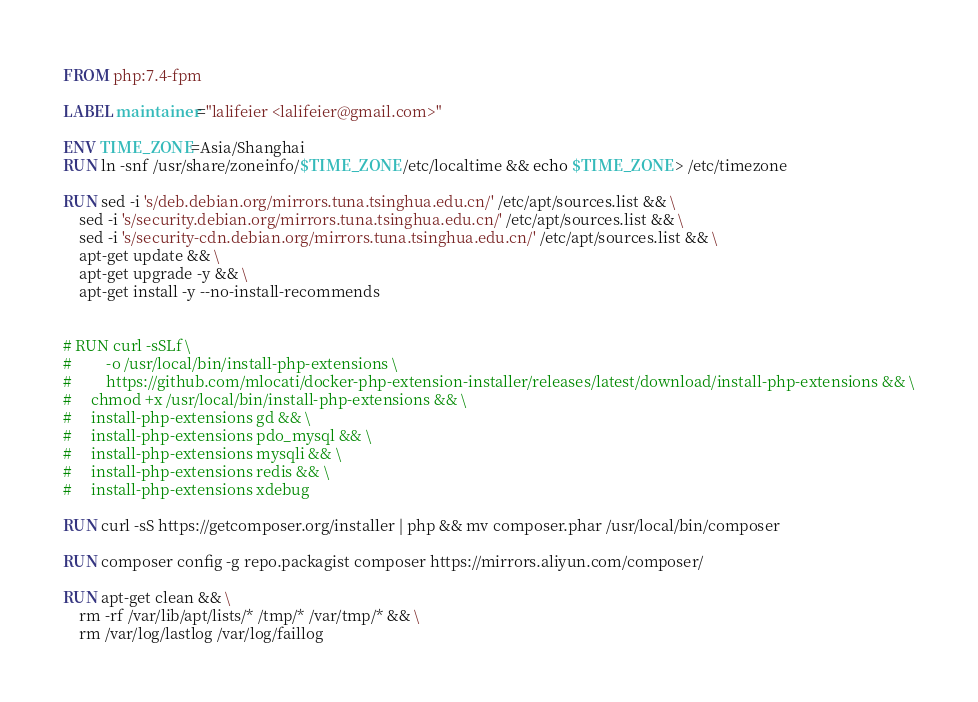Convert code to text. <code><loc_0><loc_0><loc_500><loc_500><_Dockerfile_>FROM php:7.4-fpm

LABEL maintainer="lalifeier <lalifeier@gmail.com>"

ENV TIME_ZONE=Asia/Shanghai
RUN ln -snf /usr/share/zoneinfo/$TIME_ZONE /etc/localtime && echo $TIME_ZONE > /etc/timezone

RUN sed -i 's/deb.debian.org/mirrors.tuna.tsinghua.edu.cn/' /etc/apt/sources.list && \
    sed -i 's/security.debian.org/mirrors.tuna.tsinghua.edu.cn/' /etc/apt/sources.list && \
    sed -i 's/security-cdn.debian.org/mirrors.tuna.tsinghua.edu.cn/' /etc/apt/sources.list && \
    apt-get update && \
    apt-get upgrade -y && \
    apt-get install -y --no-install-recommends


# RUN curl -sSLf \
#         -o /usr/local/bin/install-php-extensions \
#         https://github.com/mlocati/docker-php-extension-installer/releases/latest/download/install-php-extensions && \
#     chmod +x /usr/local/bin/install-php-extensions && \
#     install-php-extensions gd && \
#     install-php-extensions pdo_mysql && \
#     install-php-extensions mysqli && \
#     install-php-extensions redis && \
#     install-php-extensions xdebug

RUN curl -sS https://getcomposer.org/installer | php && mv composer.phar /usr/local/bin/composer

RUN composer config -g repo.packagist composer https://mirrors.aliyun.com/composer/

RUN apt-get clean && \
    rm -rf /var/lib/apt/lists/* /tmp/* /var/tmp/* && \
    rm /var/log/lastlog /var/log/faillog
</code> 